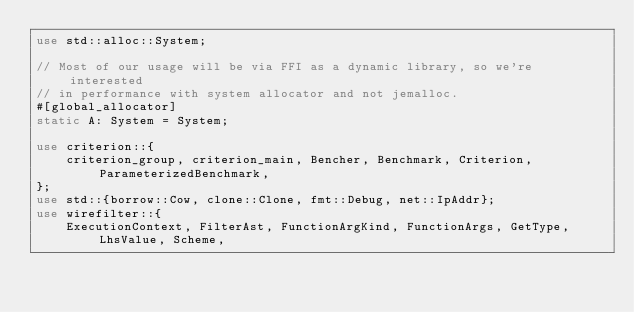<code> <loc_0><loc_0><loc_500><loc_500><_Rust_>use std::alloc::System;

// Most of our usage will be via FFI as a dynamic library, so we're interested
// in performance with system allocator and not jemalloc.
#[global_allocator]
static A: System = System;

use criterion::{
    criterion_group, criterion_main, Bencher, Benchmark, Criterion, ParameterizedBenchmark,
};
use std::{borrow::Cow, clone::Clone, fmt::Debug, net::IpAddr};
use wirefilter::{
    ExecutionContext, FilterAst, FunctionArgKind, FunctionArgs, GetType, LhsValue, Scheme,</code> 